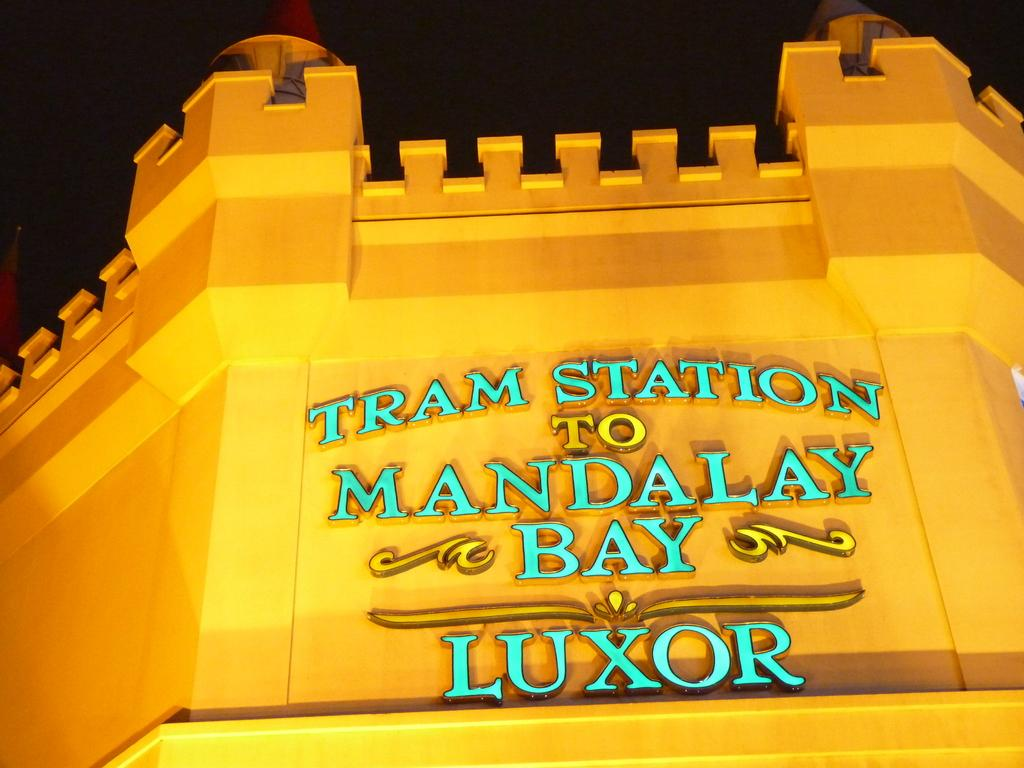What is the main subject of the image? The main subject of the image is a building. Are there any words or letters on the building? Yes, there is text on the building. What can be observed about the background of the image? The background of the image is dark. Can you tell me how many keys are hanging on the wall in the image? There are no keys present in the image; it only features a building with text on it and a dark background. 